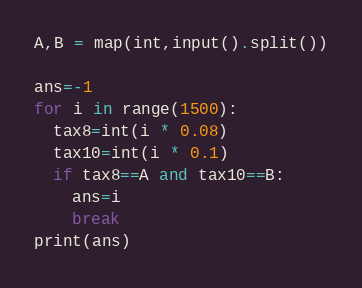Convert code to text. <code><loc_0><loc_0><loc_500><loc_500><_Python_>A,B = map(int,input().split())

ans=-1
for i in range(1500):
  tax8=int(i * 0.08)
  tax10=int(i * 0.1)
  if tax8==A and tax10==B:
    ans=i
    break
print(ans)</code> 